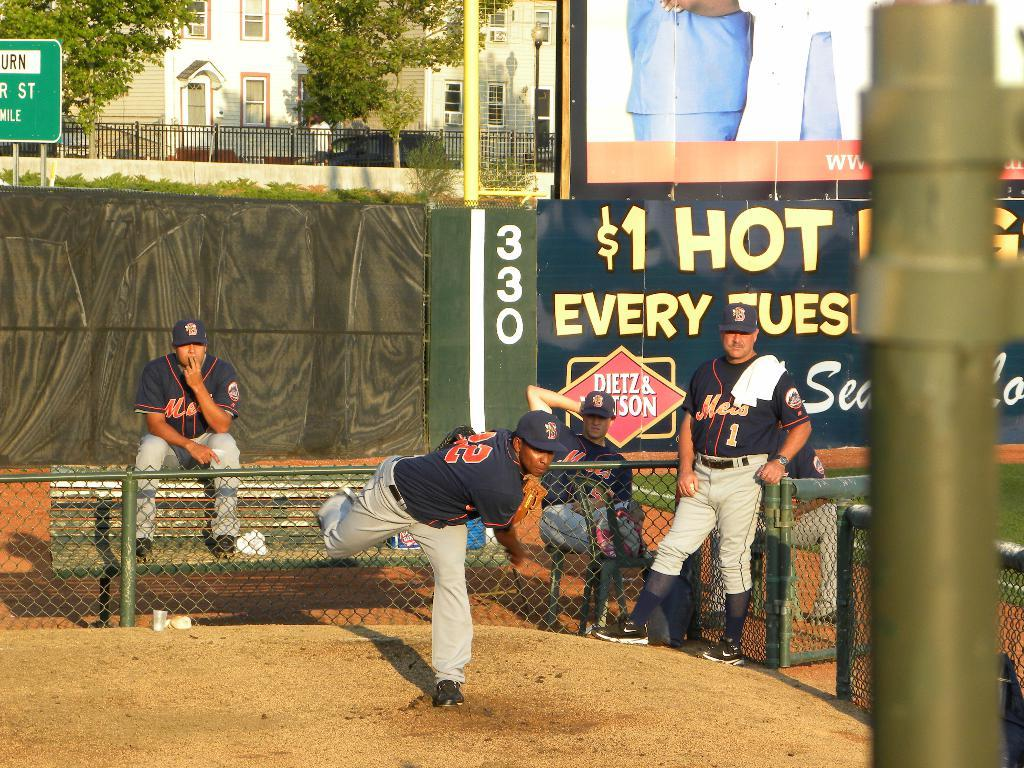<image>
Write a terse but informative summary of the picture. Three men in Mets uniforms watch another man throw a ball. 